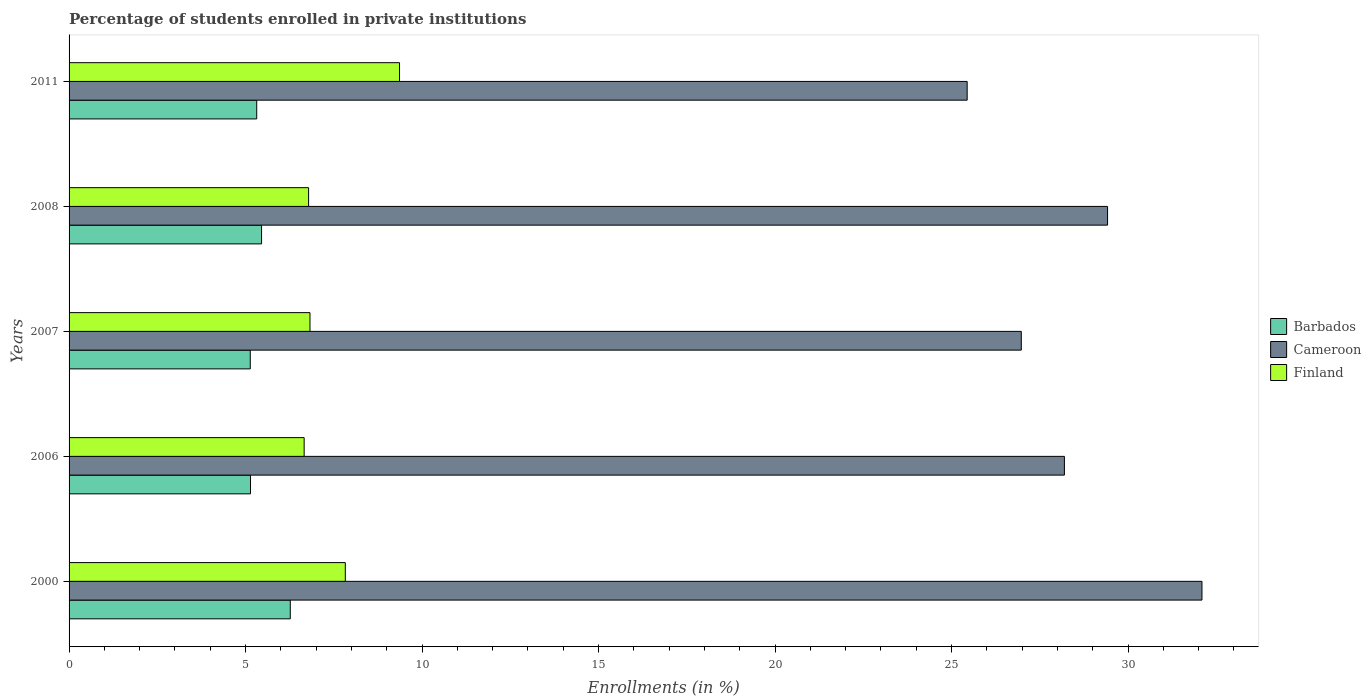Are the number of bars on each tick of the Y-axis equal?
Your answer should be compact. Yes. How many bars are there on the 4th tick from the top?
Offer a terse response. 3. In how many cases, is the number of bars for a given year not equal to the number of legend labels?
Ensure brevity in your answer.  0. What is the percentage of trained teachers in Barbados in 2006?
Your answer should be very brief. 5.14. Across all years, what is the maximum percentage of trained teachers in Finland?
Give a very brief answer. 9.36. Across all years, what is the minimum percentage of trained teachers in Finland?
Provide a succinct answer. 6.66. In which year was the percentage of trained teachers in Finland maximum?
Offer a very short reply. 2011. What is the total percentage of trained teachers in Cameroon in the graph?
Your response must be concise. 142.13. What is the difference between the percentage of trained teachers in Cameroon in 2007 and that in 2011?
Your answer should be very brief. 1.53. What is the difference between the percentage of trained teachers in Barbados in 2006 and the percentage of trained teachers in Finland in 2011?
Ensure brevity in your answer.  -4.22. What is the average percentage of trained teachers in Cameroon per year?
Offer a terse response. 28.43. In the year 2008, what is the difference between the percentage of trained teachers in Cameroon and percentage of trained teachers in Finland?
Ensure brevity in your answer.  22.63. In how many years, is the percentage of trained teachers in Barbados greater than 9 %?
Your answer should be very brief. 0. What is the ratio of the percentage of trained teachers in Cameroon in 2008 to that in 2011?
Make the answer very short. 1.16. Is the percentage of trained teachers in Barbados in 2000 less than that in 2008?
Your answer should be compact. No. Is the difference between the percentage of trained teachers in Cameroon in 2006 and 2011 greater than the difference between the percentage of trained teachers in Finland in 2006 and 2011?
Give a very brief answer. Yes. What is the difference between the highest and the second highest percentage of trained teachers in Cameroon?
Keep it short and to the point. 2.67. What is the difference between the highest and the lowest percentage of trained teachers in Barbados?
Provide a short and direct response. 1.13. What does the 3rd bar from the top in 2006 represents?
Provide a succinct answer. Barbados. What does the 1st bar from the bottom in 2006 represents?
Offer a very short reply. Barbados. How many bars are there?
Make the answer very short. 15. How many years are there in the graph?
Ensure brevity in your answer.  5. Are the values on the major ticks of X-axis written in scientific E-notation?
Provide a short and direct response. No. How are the legend labels stacked?
Give a very brief answer. Vertical. What is the title of the graph?
Offer a terse response. Percentage of students enrolled in private institutions. What is the label or title of the X-axis?
Provide a succinct answer. Enrollments (in %). What is the label or title of the Y-axis?
Your response must be concise. Years. What is the Enrollments (in %) of Barbados in 2000?
Offer a terse response. 6.27. What is the Enrollments (in %) of Cameroon in 2000?
Provide a succinct answer. 32.09. What is the Enrollments (in %) of Finland in 2000?
Keep it short and to the point. 7.83. What is the Enrollments (in %) in Barbados in 2006?
Offer a very short reply. 5.14. What is the Enrollments (in %) of Cameroon in 2006?
Provide a succinct answer. 28.2. What is the Enrollments (in %) of Finland in 2006?
Keep it short and to the point. 6.66. What is the Enrollments (in %) in Barbados in 2007?
Offer a very short reply. 5.13. What is the Enrollments (in %) of Cameroon in 2007?
Your answer should be very brief. 26.98. What is the Enrollments (in %) in Finland in 2007?
Your answer should be compact. 6.82. What is the Enrollments (in %) of Barbados in 2008?
Make the answer very short. 5.45. What is the Enrollments (in %) in Cameroon in 2008?
Your response must be concise. 29.42. What is the Enrollments (in %) in Finland in 2008?
Provide a succinct answer. 6.79. What is the Enrollments (in %) of Barbados in 2011?
Keep it short and to the point. 5.32. What is the Enrollments (in %) in Cameroon in 2011?
Your response must be concise. 25.44. What is the Enrollments (in %) of Finland in 2011?
Offer a terse response. 9.36. Across all years, what is the maximum Enrollments (in %) of Barbados?
Make the answer very short. 6.27. Across all years, what is the maximum Enrollments (in %) of Cameroon?
Your answer should be very brief. 32.09. Across all years, what is the maximum Enrollments (in %) of Finland?
Provide a succinct answer. 9.36. Across all years, what is the minimum Enrollments (in %) of Barbados?
Your response must be concise. 5.13. Across all years, what is the minimum Enrollments (in %) in Cameroon?
Your answer should be compact. 25.44. Across all years, what is the minimum Enrollments (in %) of Finland?
Your response must be concise. 6.66. What is the total Enrollments (in %) of Barbados in the graph?
Provide a succinct answer. 27.31. What is the total Enrollments (in %) in Cameroon in the graph?
Offer a terse response. 142.13. What is the total Enrollments (in %) in Finland in the graph?
Offer a very short reply. 37.46. What is the difference between the Enrollments (in %) of Barbados in 2000 and that in 2006?
Your response must be concise. 1.13. What is the difference between the Enrollments (in %) in Cameroon in 2000 and that in 2006?
Make the answer very short. 3.9. What is the difference between the Enrollments (in %) in Finland in 2000 and that in 2006?
Ensure brevity in your answer.  1.17. What is the difference between the Enrollments (in %) in Barbados in 2000 and that in 2007?
Make the answer very short. 1.13. What is the difference between the Enrollments (in %) of Cameroon in 2000 and that in 2007?
Offer a terse response. 5.12. What is the difference between the Enrollments (in %) in Finland in 2000 and that in 2007?
Your response must be concise. 1. What is the difference between the Enrollments (in %) of Barbados in 2000 and that in 2008?
Provide a succinct answer. 0.81. What is the difference between the Enrollments (in %) of Cameroon in 2000 and that in 2008?
Your response must be concise. 2.67. What is the difference between the Enrollments (in %) in Finland in 2000 and that in 2008?
Give a very brief answer. 1.04. What is the difference between the Enrollments (in %) in Barbados in 2000 and that in 2011?
Provide a succinct answer. 0.95. What is the difference between the Enrollments (in %) in Cameroon in 2000 and that in 2011?
Your answer should be compact. 6.65. What is the difference between the Enrollments (in %) in Finland in 2000 and that in 2011?
Keep it short and to the point. -1.54. What is the difference between the Enrollments (in %) in Barbados in 2006 and that in 2007?
Make the answer very short. 0.01. What is the difference between the Enrollments (in %) of Cameroon in 2006 and that in 2007?
Provide a short and direct response. 1.22. What is the difference between the Enrollments (in %) of Finland in 2006 and that in 2007?
Make the answer very short. -0.17. What is the difference between the Enrollments (in %) in Barbados in 2006 and that in 2008?
Provide a succinct answer. -0.31. What is the difference between the Enrollments (in %) of Cameroon in 2006 and that in 2008?
Your answer should be compact. -1.22. What is the difference between the Enrollments (in %) of Finland in 2006 and that in 2008?
Offer a terse response. -0.13. What is the difference between the Enrollments (in %) of Barbados in 2006 and that in 2011?
Provide a succinct answer. -0.18. What is the difference between the Enrollments (in %) in Cameroon in 2006 and that in 2011?
Ensure brevity in your answer.  2.75. What is the difference between the Enrollments (in %) in Finland in 2006 and that in 2011?
Ensure brevity in your answer.  -2.7. What is the difference between the Enrollments (in %) of Barbados in 2007 and that in 2008?
Your answer should be compact. -0.32. What is the difference between the Enrollments (in %) of Cameroon in 2007 and that in 2008?
Make the answer very short. -2.44. What is the difference between the Enrollments (in %) of Finland in 2007 and that in 2008?
Your response must be concise. 0.04. What is the difference between the Enrollments (in %) in Barbados in 2007 and that in 2011?
Your response must be concise. -0.18. What is the difference between the Enrollments (in %) of Cameroon in 2007 and that in 2011?
Offer a terse response. 1.53. What is the difference between the Enrollments (in %) in Finland in 2007 and that in 2011?
Offer a terse response. -2.54. What is the difference between the Enrollments (in %) in Barbados in 2008 and that in 2011?
Make the answer very short. 0.14. What is the difference between the Enrollments (in %) in Cameroon in 2008 and that in 2011?
Offer a terse response. 3.98. What is the difference between the Enrollments (in %) of Finland in 2008 and that in 2011?
Offer a very short reply. -2.58. What is the difference between the Enrollments (in %) in Barbados in 2000 and the Enrollments (in %) in Cameroon in 2006?
Make the answer very short. -21.93. What is the difference between the Enrollments (in %) in Barbados in 2000 and the Enrollments (in %) in Finland in 2006?
Make the answer very short. -0.39. What is the difference between the Enrollments (in %) of Cameroon in 2000 and the Enrollments (in %) of Finland in 2006?
Your answer should be compact. 25.43. What is the difference between the Enrollments (in %) of Barbados in 2000 and the Enrollments (in %) of Cameroon in 2007?
Provide a short and direct response. -20.71. What is the difference between the Enrollments (in %) of Barbados in 2000 and the Enrollments (in %) of Finland in 2007?
Ensure brevity in your answer.  -0.56. What is the difference between the Enrollments (in %) in Cameroon in 2000 and the Enrollments (in %) in Finland in 2007?
Give a very brief answer. 25.27. What is the difference between the Enrollments (in %) of Barbados in 2000 and the Enrollments (in %) of Cameroon in 2008?
Make the answer very short. -23.15. What is the difference between the Enrollments (in %) of Barbados in 2000 and the Enrollments (in %) of Finland in 2008?
Give a very brief answer. -0.52. What is the difference between the Enrollments (in %) in Cameroon in 2000 and the Enrollments (in %) in Finland in 2008?
Your response must be concise. 25.31. What is the difference between the Enrollments (in %) in Barbados in 2000 and the Enrollments (in %) in Cameroon in 2011?
Provide a short and direct response. -19.18. What is the difference between the Enrollments (in %) in Barbados in 2000 and the Enrollments (in %) in Finland in 2011?
Make the answer very short. -3.09. What is the difference between the Enrollments (in %) of Cameroon in 2000 and the Enrollments (in %) of Finland in 2011?
Ensure brevity in your answer.  22.73. What is the difference between the Enrollments (in %) in Barbados in 2006 and the Enrollments (in %) in Cameroon in 2007?
Keep it short and to the point. -21.84. What is the difference between the Enrollments (in %) in Barbados in 2006 and the Enrollments (in %) in Finland in 2007?
Keep it short and to the point. -1.68. What is the difference between the Enrollments (in %) in Cameroon in 2006 and the Enrollments (in %) in Finland in 2007?
Provide a short and direct response. 21.37. What is the difference between the Enrollments (in %) in Barbados in 2006 and the Enrollments (in %) in Cameroon in 2008?
Offer a very short reply. -24.28. What is the difference between the Enrollments (in %) of Barbados in 2006 and the Enrollments (in %) of Finland in 2008?
Provide a succinct answer. -1.64. What is the difference between the Enrollments (in %) in Cameroon in 2006 and the Enrollments (in %) in Finland in 2008?
Give a very brief answer. 21.41. What is the difference between the Enrollments (in %) of Barbados in 2006 and the Enrollments (in %) of Cameroon in 2011?
Make the answer very short. -20.3. What is the difference between the Enrollments (in %) of Barbados in 2006 and the Enrollments (in %) of Finland in 2011?
Your answer should be compact. -4.22. What is the difference between the Enrollments (in %) of Cameroon in 2006 and the Enrollments (in %) of Finland in 2011?
Make the answer very short. 18.83. What is the difference between the Enrollments (in %) of Barbados in 2007 and the Enrollments (in %) of Cameroon in 2008?
Keep it short and to the point. -24.29. What is the difference between the Enrollments (in %) of Barbados in 2007 and the Enrollments (in %) of Finland in 2008?
Ensure brevity in your answer.  -1.65. What is the difference between the Enrollments (in %) of Cameroon in 2007 and the Enrollments (in %) of Finland in 2008?
Provide a short and direct response. 20.19. What is the difference between the Enrollments (in %) of Barbados in 2007 and the Enrollments (in %) of Cameroon in 2011?
Give a very brief answer. -20.31. What is the difference between the Enrollments (in %) of Barbados in 2007 and the Enrollments (in %) of Finland in 2011?
Offer a very short reply. -4.23. What is the difference between the Enrollments (in %) in Cameroon in 2007 and the Enrollments (in %) in Finland in 2011?
Your response must be concise. 17.61. What is the difference between the Enrollments (in %) in Barbados in 2008 and the Enrollments (in %) in Cameroon in 2011?
Ensure brevity in your answer.  -19.99. What is the difference between the Enrollments (in %) of Barbados in 2008 and the Enrollments (in %) of Finland in 2011?
Give a very brief answer. -3.91. What is the difference between the Enrollments (in %) of Cameroon in 2008 and the Enrollments (in %) of Finland in 2011?
Ensure brevity in your answer.  20.06. What is the average Enrollments (in %) in Barbados per year?
Offer a very short reply. 5.46. What is the average Enrollments (in %) in Cameroon per year?
Provide a short and direct response. 28.43. What is the average Enrollments (in %) in Finland per year?
Keep it short and to the point. 7.49. In the year 2000, what is the difference between the Enrollments (in %) of Barbados and Enrollments (in %) of Cameroon?
Give a very brief answer. -25.83. In the year 2000, what is the difference between the Enrollments (in %) of Barbados and Enrollments (in %) of Finland?
Give a very brief answer. -1.56. In the year 2000, what is the difference between the Enrollments (in %) of Cameroon and Enrollments (in %) of Finland?
Offer a terse response. 24.27. In the year 2006, what is the difference between the Enrollments (in %) in Barbados and Enrollments (in %) in Cameroon?
Ensure brevity in your answer.  -23.06. In the year 2006, what is the difference between the Enrollments (in %) in Barbados and Enrollments (in %) in Finland?
Your response must be concise. -1.52. In the year 2006, what is the difference between the Enrollments (in %) in Cameroon and Enrollments (in %) in Finland?
Make the answer very short. 21.54. In the year 2007, what is the difference between the Enrollments (in %) in Barbados and Enrollments (in %) in Cameroon?
Make the answer very short. -21.84. In the year 2007, what is the difference between the Enrollments (in %) in Barbados and Enrollments (in %) in Finland?
Provide a short and direct response. -1.69. In the year 2007, what is the difference between the Enrollments (in %) of Cameroon and Enrollments (in %) of Finland?
Offer a terse response. 20.15. In the year 2008, what is the difference between the Enrollments (in %) of Barbados and Enrollments (in %) of Cameroon?
Your answer should be compact. -23.97. In the year 2008, what is the difference between the Enrollments (in %) in Barbados and Enrollments (in %) in Finland?
Provide a succinct answer. -1.33. In the year 2008, what is the difference between the Enrollments (in %) in Cameroon and Enrollments (in %) in Finland?
Keep it short and to the point. 22.63. In the year 2011, what is the difference between the Enrollments (in %) of Barbados and Enrollments (in %) of Cameroon?
Provide a succinct answer. -20.13. In the year 2011, what is the difference between the Enrollments (in %) of Barbados and Enrollments (in %) of Finland?
Offer a terse response. -4.05. In the year 2011, what is the difference between the Enrollments (in %) in Cameroon and Enrollments (in %) in Finland?
Offer a terse response. 16.08. What is the ratio of the Enrollments (in %) in Barbados in 2000 to that in 2006?
Your answer should be very brief. 1.22. What is the ratio of the Enrollments (in %) in Cameroon in 2000 to that in 2006?
Keep it short and to the point. 1.14. What is the ratio of the Enrollments (in %) of Finland in 2000 to that in 2006?
Make the answer very short. 1.18. What is the ratio of the Enrollments (in %) of Barbados in 2000 to that in 2007?
Provide a short and direct response. 1.22. What is the ratio of the Enrollments (in %) in Cameroon in 2000 to that in 2007?
Make the answer very short. 1.19. What is the ratio of the Enrollments (in %) in Finland in 2000 to that in 2007?
Provide a succinct answer. 1.15. What is the ratio of the Enrollments (in %) in Barbados in 2000 to that in 2008?
Provide a succinct answer. 1.15. What is the ratio of the Enrollments (in %) of Cameroon in 2000 to that in 2008?
Give a very brief answer. 1.09. What is the ratio of the Enrollments (in %) of Finland in 2000 to that in 2008?
Your answer should be very brief. 1.15. What is the ratio of the Enrollments (in %) in Barbados in 2000 to that in 2011?
Offer a terse response. 1.18. What is the ratio of the Enrollments (in %) in Cameroon in 2000 to that in 2011?
Your response must be concise. 1.26. What is the ratio of the Enrollments (in %) of Finland in 2000 to that in 2011?
Keep it short and to the point. 0.84. What is the ratio of the Enrollments (in %) of Barbados in 2006 to that in 2007?
Your response must be concise. 1. What is the ratio of the Enrollments (in %) of Cameroon in 2006 to that in 2007?
Ensure brevity in your answer.  1.05. What is the ratio of the Enrollments (in %) in Finland in 2006 to that in 2007?
Make the answer very short. 0.98. What is the ratio of the Enrollments (in %) of Barbados in 2006 to that in 2008?
Offer a very short reply. 0.94. What is the ratio of the Enrollments (in %) of Cameroon in 2006 to that in 2008?
Keep it short and to the point. 0.96. What is the ratio of the Enrollments (in %) of Finland in 2006 to that in 2008?
Your response must be concise. 0.98. What is the ratio of the Enrollments (in %) in Cameroon in 2006 to that in 2011?
Ensure brevity in your answer.  1.11. What is the ratio of the Enrollments (in %) of Finland in 2006 to that in 2011?
Provide a short and direct response. 0.71. What is the ratio of the Enrollments (in %) of Barbados in 2007 to that in 2008?
Give a very brief answer. 0.94. What is the ratio of the Enrollments (in %) of Cameroon in 2007 to that in 2008?
Ensure brevity in your answer.  0.92. What is the ratio of the Enrollments (in %) in Barbados in 2007 to that in 2011?
Your answer should be compact. 0.97. What is the ratio of the Enrollments (in %) of Cameroon in 2007 to that in 2011?
Keep it short and to the point. 1.06. What is the ratio of the Enrollments (in %) of Finland in 2007 to that in 2011?
Provide a short and direct response. 0.73. What is the ratio of the Enrollments (in %) of Barbados in 2008 to that in 2011?
Keep it short and to the point. 1.03. What is the ratio of the Enrollments (in %) of Cameroon in 2008 to that in 2011?
Provide a short and direct response. 1.16. What is the ratio of the Enrollments (in %) in Finland in 2008 to that in 2011?
Keep it short and to the point. 0.72. What is the difference between the highest and the second highest Enrollments (in %) of Barbados?
Your response must be concise. 0.81. What is the difference between the highest and the second highest Enrollments (in %) in Cameroon?
Your answer should be compact. 2.67. What is the difference between the highest and the second highest Enrollments (in %) in Finland?
Your answer should be compact. 1.54. What is the difference between the highest and the lowest Enrollments (in %) of Barbados?
Your response must be concise. 1.13. What is the difference between the highest and the lowest Enrollments (in %) in Cameroon?
Keep it short and to the point. 6.65. What is the difference between the highest and the lowest Enrollments (in %) of Finland?
Offer a very short reply. 2.7. 